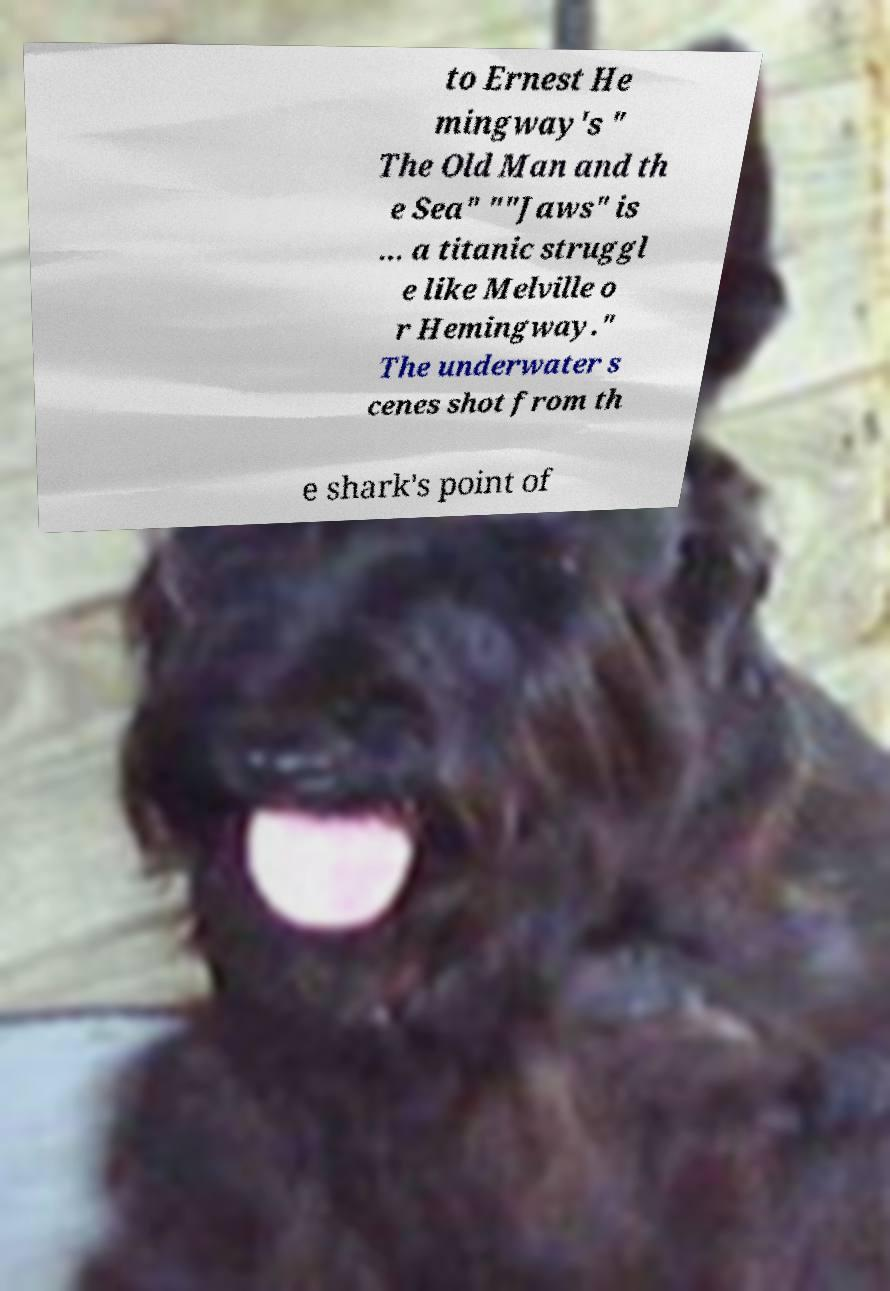I need the written content from this picture converted into text. Can you do that? to Ernest He mingway's " The Old Man and th e Sea" ""Jaws" is ... a titanic struggl e like Melville o r Hemingway." The underwater s cenes shot from th e shark's point of 